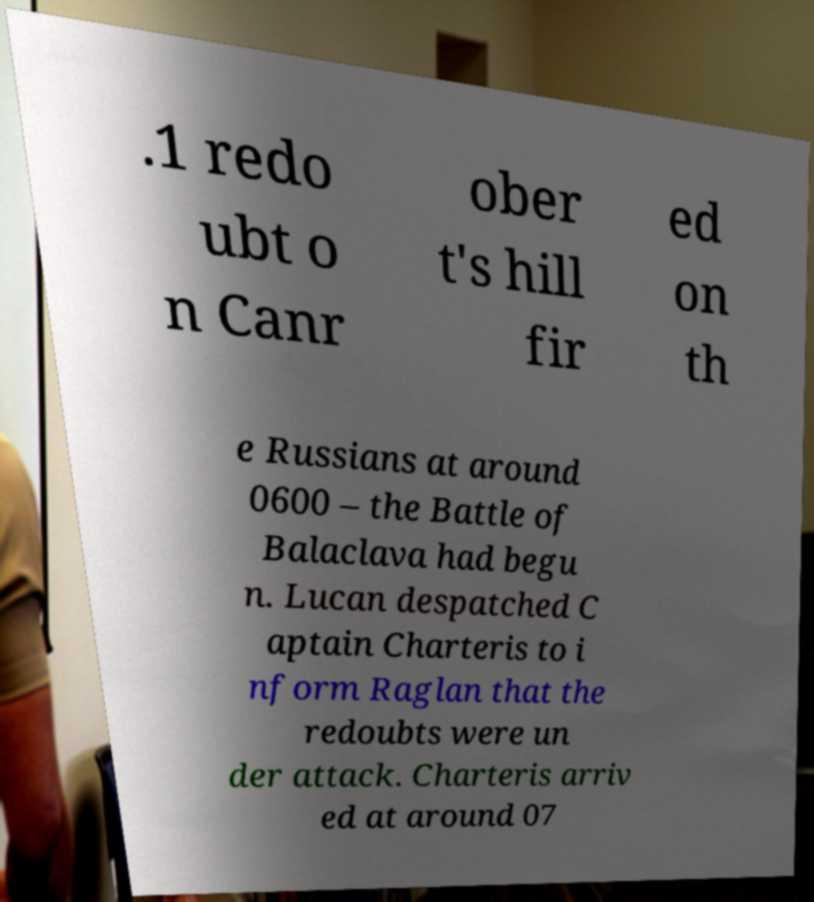There's text embedded in this image that I need extracted. Can you transcribe it verbatim? .1 redo ubt o n Canr ober t's hill fir ed on th e Russians at around 0600 – the Battle of Balaclava had begu n. Lucan despatched C aptain Charteris to i nform Raglan that the redoubts were un der attack. Charteris arriv ed at around 07 